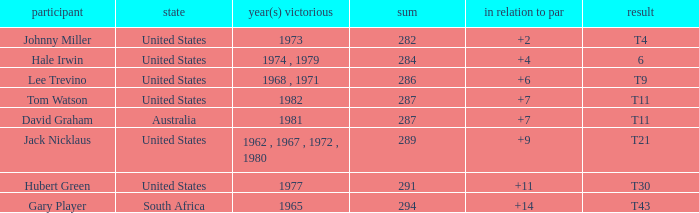WHAT IS THE TO PAR WITH A FINISH OF T11, FOR DAVID GRAHAM? 7.0. 